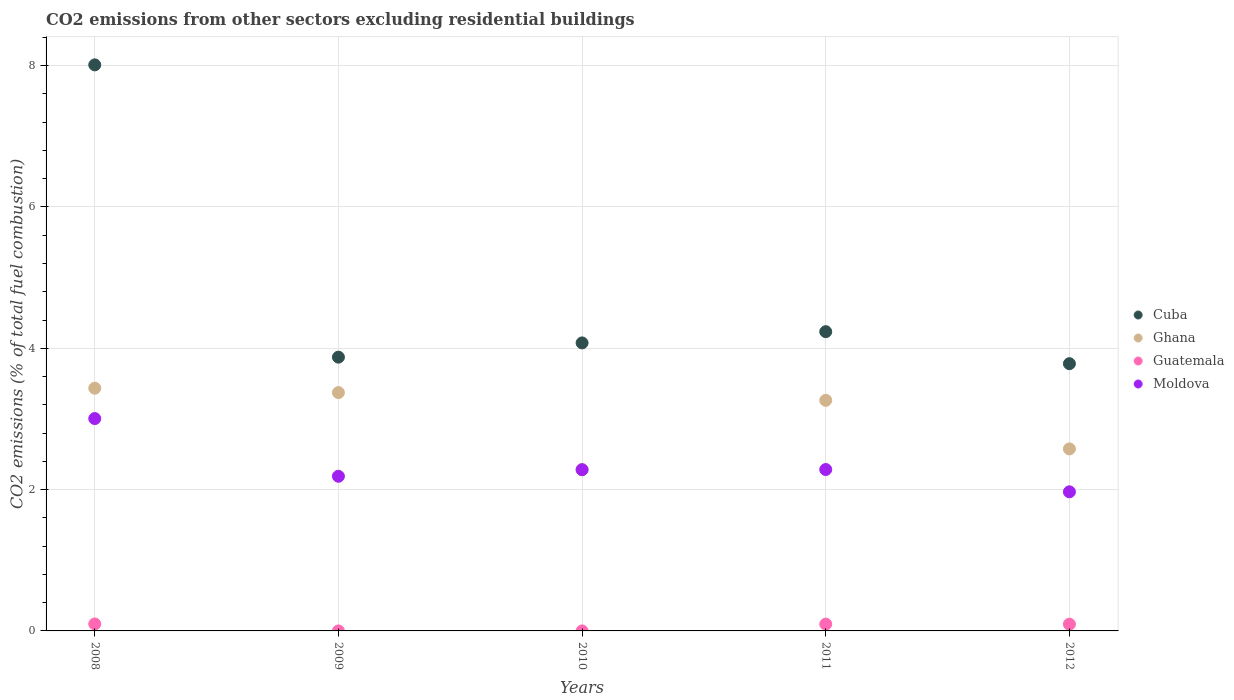How many different coloured dotlines are there?
Provide a succinct answer. 4. Is the number of dotlines equal to the number of legend labels?
Provide a short and direct response. Yes. What is the total CO2 emitted in Ghana in 2010?
Your answer should be compact. 2.28. Across all years, what is the maximum total CO2 emitted in Moldova?
Ensure brevity in your answer.  3.01. Across all years, what is the minimum total CO2 emitted in Ghana?
Ensure brevity in your answer.  2.28. What is the total total CO2 emitted in Cuba in the graph?
Make the answer very short. 23.98. What is the difference between the total CO2 emitted in Moldova in 2009 and that in 2010?
Your answer should be very brief. -0.09. What is the difference between the total CO2 emitted in Ghana in 2008 and the total CO2 emitted in Moldova in 2009?
Your response must be concise. 1.25. What is the average total CO2 emitted in Cuba per year?
Your response must be concise. 4.8. In the year 2012, what is the difference between the total CO2 emitted in Cuba and total CO2 emitted in Ghana?
Your answer should be compact. 1.21. What is the ratio of the total CO2 emitted in Moldova in 2009 to that in 2012?
Offer a very short reply. 1.11. Is the total CO2 emitted in Guatemala in 2008 less than that in 2011?
Keep it short and to the point. No. Is the difference between the total CO2 emitted in Cuba in 2009 and 2011 greater than the difference between the total CO2 emitted in Ghana in 2009 and 2011?
Give a very brief answer. No. What is the difference between the highest and the second highest total CO2 emitted in Ghana?
Offer a very short reply. 0.06. What is the difference between the highest and the lowest total CO2 emitted in Ghana?
Offer a very short reply. 1.15. Is it the case that in every year, the sum of the total CO2 emitted in Ghana and total CO2 emitted in Guatemala  is greater than the sum of total CO2 emitted in Moldova and total CO2 emitted in Cuba?
Provide a short and direct response. No. Does the total CO2 emitted in Moldova monotonically increase over the years?
Ensure brevity in your answer.  No. Is the total CO2 emitted in Ghana strictly less than the total CO2 emitted in Cuba over the years?
Offer a terse response. Yes. How many years are there in the graph?
Offer a terse response. 5. Are the values on the major ticks of Y-axis written in scientific E-notation?
Your answer should be very brief. No. Where does the legend appear in the graph?
Ensure brevity in your answer.  Center right. How are the legend labels stacked?
Keep it short and to the point. Vertical. What is the title of the graph?
Give a very brief answer. CO2 emissions from other sectors excluding residential buildings. What is the label or title of the Y-axis?
Provide a short and direct response. CO2 emissions (% of total fuel combustion). What is the CO2 emissions (% of total fuel combustion) in Cuba in 2008?
Make the answer very short. 8.01. What is the CO2 emissions (% of total fuel combustion) in Ghana in 2008?
Your answer should be very brief. 3.44. What is the CO2 emissions (% of total fuel combustion) of Guatemala in 2008?
Your response must be concise. 0.1. What is the CO2 emissions (% of total fuel combustion) of Moldova in 2008?
Ensure brevity in your answer.  3.01. What is the CO2 emissions (% of total fuel combustion) in Cuba in 2009?
Your answer should be very brief. 3.87. What is the CO2 emissions (% of total fuel combustion) of Ghana in 2009?
Make the answer very short. 3.37. What is the CO2 emissions (% of total fuel combustion) in Guatemala in 2009?
Ensure brevity in your answer.  7.793007529096171e-17. What is the CO2 emissions (% of total fuel combustion) of Moldova in 2009?
Ensure brevity in your answer.  2.19. What is the CO2 emissions (% of total fuel combustion) of Cuba in 2010?
Offer a terse response. 4.08. What is the CO2 emissions (% of total fuel combustion) in Ghana in 2010?
Your response must be concise. 2.28. What is the CO2 emissions (% of total fuel combustion) in Guatemala in 2010?
Your answer should be very brief. 1.6957218729001e-16. What is the CO2 emissions (% of total fuel combustion) in Moldova in 2010?
Offer a terse response. 2.28. What is the CO2 emissions (% of total fuel combustion) of Cuba in 2011?
Offer a terse response. 4.24. What is the CO2 emissions (% of total fuel combustion) of Ghana in 2011?
Your answer should be compact. 3.26. What is the CO2 emissions (% of total fuel combustion) in Guatemala in 2011?
Provide a succinct answer. 0.1. What is the CO2 emissions (% of total fuel combustion) in Moldova in 2011?
Make the answer very short. 2.28. What is the CO2 emissions (% of total fuel combustion) in Cuba in 2012?
Provide a succinct answer. 3.78. What is the CO2 emissions (% of total fuel combustion) of Ghana in 2012?
Your answer should be very brief. 2.58. What is the CO2 emissions (% of total fuel combustion) of Guatemala in 2012?
Keep it short and to the point. 0.1. What is the CO2 emissions (% of total fuel combustion) of Moldova in 2012?
Offer a terse response. 1.97. Across all years, what is the maximum CO2 emissions (% of total fuel combustion) of Cuba?
Your answer should be very brief. 8.01. Across all years, what is the maximum CO2 emissions (% of total fuel combustion) of Ghana?
Give a very brief answer. 3.44. Across all years, what is the maximum CO2 emissions (% of total fuel combustion) in Guatemala?
Keep it short and to the point. 0.1. Across all years, what is the maximum CO2 emissions (% of total fuel combustion) of Moldova?
Keep it short and to the point. 3.01. Across all years, what is the minimum CO2 emissions (% of total fuel combustion) in Cuba?
Offer a terse response. 3.78. Across all years, what is the minimum CO2 emissions (% of total fuel combustion) in Ghana?
Your answer should be compact. 2.28. Across all years, what is the minimum CO2 emissions (% of total fuel combustion) in Guatemala?
Provide a succinct answer. 7.793007529096171e-17. Across all years, what is the minimum CO2 emissions (% of total fuel combustion) of Moldova?
Your answer should be very brief. 1.97. What is the total CO2 emissions (% of total fuel combustion) in Cuba in the graph?
Offer a very short reply. 23.98. What is the total CO2 emissions (% of total fuel combustion) in Ghana in the graph?
Offer a very short reply. 14.93. What is the total CO2 emissions (% of total fuel combustion) in Guatemala in the graph?
Make the answer very short. 0.29. What is the total CO2 emissions (% of total fuel combustion) of Moldova in the graph?
Provide a succinct answer. 11.73. What is the difference between the CO2 emissions (% of total fuel combustion) in Cuba in 2008 and that in 2009?
Your answer should be compact. 4.14. What is the difference between the CO2 emissions (% of total fuel combustion) in Ghana in 2008 and that in 2009?
Provide a short and direct response. 0.06. What is the difference between the CO2 emissions (% of total fuel combustion) in Guatemala in 2008 and that in 2009?
Ensure brevity in your answer.  0.1. What is the difference between the CO2 emissions (% of total fuel combustion) in Moldova in 2008 and that in 2009?
Your response must be concise. 0.82. What is the difference between the CO2 emissions (% of total fuel combustion) of Cuba in 2008 and that in 2010?
Provide a short and direct response. 3.94. What is the difference between the CO2 emissions (% of total fuel combustion) of Ghana in 2008 and that in 2010?
Your answer should be very brief. 1.15. What is the difference between the CO2 emissions (% of total fuel combustion) in Guatemala in 2008 and that in 2010?
Offer a terse response. 0.1. What is the difference between the CO2 emissions (% of total fuel combustion) in Moldova in 2008 and that in 2010?
Your response must be concise. 0.72. What is the difference between the CO2 emissions (% of total fuel combustion) of Cuba in 2008 and that in 2011?
Offer a very short reply. 3.78. What is the difference between the CO2 emissions (% of total fuel combustion) in Ghana in 2008 and that in 2011?
Your answer should be compact. 0.17. What is the difference between the CO2 emissions (% of total fuel combustion) of Guatemala in 2008 and that in 2011?
Ensure brevity in your answer.  0. What is the difference between the CO2 emissions (% of total fuel combustion) in Moldova in 2008 and that in 2011?
Offer a terse response. 0.72. What is the difference between the CO2 emissions (% of total fuel combustion) in Cuba in 2008 and that in 2012?
Offer a very short reply. 4.23. What is the difference between the CO2 emissions (% of total fuel combustion) in Ghana in 2008 and that in 2012?
Provide a short and direct response. 0.86. What is the difference between the CO2 emissions (% of total fuel combustion) of Guatemala in 2008 and that in 2012?
Offer a terse response. 0. What is the difference between the CO2 emissions (% of total fuel combustion) of Cuba in 2009 and that in 2010?
Keep it short and to the point. -0.2. What is the difference between the CO2 emissions (% of total fuel combustion) in Ghana in 2009 and that in 2010?
Make the answer very short. 1.09. What is the difference between the CO2 emissions (% of total fuel combustion) of Moldova in 2009 and that in 2010?
Your response must be concise. -0.09. What is the difference between the CO2 emissions (% of total fuel combustion) of Cuba in 2009 and that in 2011?
Offer a terse response. -0.36. What is the difference between the CO2 emissions (% of total fuel combustion) in Ghana in 2009 and that in 2011?
Offer a very short reply. 0.11. What is the difference between the CO2 emissions (% of total fuel combustion) of Guatemala in 2009 and that in 2011?
Provide a succinct answer. -0.1. What is the difference between the CO2 emissions (% of total fuel combustion) of Moldova in 2009 and that in 2011?
Your answer should be very brief. -0.1. What is the difference between the CO2 emissions (% of total fuel combustion) in Cuba in 2009 and that in 2012?
Your answer should be compact. 0.09. What is the difference between the CO2 emissions (% of total fuel combustion) in Ghana in 2009 and that in 2012?
Ensure brevity in your answer.  0.8. What is the difference between the CO2 emissions (% of total fuel combustion) of Guatemala in 2009 and that in 2012?
Your response must be concise. -0.1. What is the difference between the CO2 emissions (% of total fuel combustion) in Moldova in 2009 and that in 2012?
Your response must be concise. 0.22. What is the difference between the CO2 emissions (% of total fuel combustion) in Cuba in 2010 and that in 2011?
Your response must be concise. -0.16. What is the difference between the CO2 emissions (% of total fuel combustion) in Ghana in 2010 and that in 2011?
Make the answer very short. -0.98. What is the difference between the CO2 emissions (% of total fuel combustion) in Guatemala in 2010 and that in 2011?
Keep it short and to the point. -0.1. What is the difference between the CO2 emissions (% of total fuel combustion) of Moldova in 2010 and that in 2011?
Your response must be concise. -0. What is the difference between the CO2 emissions (% of total fuel combustion) of Cuba in 2010 and that in 2012?
Provide a succinct answer. 0.29. What is the difference between the CO2 emissions (% of total fuel combustion) in Ghana in 2010 and that in 2012?
Keep it short and to the point. -0.29. What is the difference between the CO2 emissions (% of total fuel combustion) in Guatemala in 2010 and that in 2012?
Your response must be concise. -0.1. What is the difference between the CO2 emissions (% of total fuel combustion) in Moldova in 2010 and that in 2012?
Make the answer very short. 0.31. What is the difference between the CO2 emissions (% of total fuel combustion) in Cuba in 2011 and that in 2012?
Keep it short and to the point. 0.45. What is the difference between the CO2 emissions (% of total fuel combustion) in Ghana in 2011 and that in 2012?
Offer a very short reply. 0.69. What is the difference between the CO2 emissions (% of total fuel combustion) in Guatemala in 2011 and that in 2012?
Offer a very short reply. 0. What is the difference between the CO2 emissions (% of total fuel combustion) in Moldova in 2011 and that in 2012?
Your response must be concise. 0.32. What is the difference between the CO2 emissions (% of total fuel combustion) in Cuba in 2008 and the CO2 emissions (% of total fuel combustion) in Ghana in 2009?
Keep it short and to the point. 4.64. What is the difference between the CO2 emissions (% of total fuel combustion) of Cuba in 2008 and the CO2 emissions (% of total fuel combustion) of Guatemala in 2009?
Keep it short and to the point. 8.01. What is the difference between the CO2 emissions (% of total fuel combustion) in Cuba in 2008 and the CO2 emissions (% of total fuel combustion) in Moldova in 2009?
Your answer should be compact. 5.82. What is the difference between the CO2 emissions (% of total fuel combustion) in Ghana in 2008 and the CO2 emissions (% of total fuel combustion) in Guatemala in 2009?
Your response must be concise. 3.44. What is the difference between the CO2 emissions (% of total fuel combustion) in Ghana in 2008 and the CO2 emissions (% of total fuel combustion) in Moldova in 2009?
Keep it short and to the point. 1.25. What is the difference between the CO2 emissions (% of total fuel combustion) in Guatemala in 2008 and the CO2 emissions (% of total fuel combustion) in Moldova in 2009?
Offer a very short reply. -2.09. What is the difference between the CO2 emissions (% of total fuel combustion) of Cuba in 2008 and the CO2 emissions (% of total fuel combustion) of Ghana in 2010?
Your answer should be very brief. 5.73. What is the difference between the CO2 emissions (% of total fuel combustion) in Cuba in 2008 and the CO2 emissions (% of total fuel combustion) in Guatemala in 2010?
Provide a short and direct response. 8.01. What is the difference between the CO2 emissions (% of total fuel combustion) of Cuba in 2008 and the CO2 emissions (% of total fuel combustion) of Moldova in 2010?
Your response must be concise. 5.73. What is the difference between the CO2 emissions (% of total fuel combustion) of Ghana in 2008 and the CO2 emissions (% of total fuel combustion) of Guatemala in 2010?
Keep it short and to the point. 3.44. What is the difference between the CO2 emissions (% of total fuel combustion) of Ghana in 2008 and the CO2 emissions (% of total fuel combustion) of Moldova in 2010?
Your answer should be very brief. 1.15. What is the difference between the CO2 emissions (% of total fuel combustion) of Guatemala in 2008 and the CO2 emissions (% of total fuel combustion) of Moldova in 2010?
Your response must be concise. -2.18. What is the difference between the CO2 emissions (% of total fuel combustion) of Cuba in 2008 and the CO2 emissions (% of total fuel combustion) of Ghana in 2011?
Make the answer very short. 4.75. What is the difference between the CO2 emissions (% of total fuel combustion) in Cuba in 2008 and the CO2 emissions (% of total fuel combustion) in Guatemala in 2011?
Your response must be concise. 7.91. What is the difference between the CO2 emissions (% of total fuel combustion) in Cuba in 2008 and the CO2 emissions (% of total fuel combustion) in Moldova in 2011?
Offer a terse response. 5.73. What is the difference between the CO2 emissions (% of total fuel combustion) in Ghana in 2008 and the CO2 emissions (% of total fuel combustion) in Guatemala in 2011?
Keep it short and to the point. 3.34. What is the difference between the CO2 emissions (% of total fuel combustion) of Ghana in 2008 and the CO2 emissions (% of total fuel combustion) of Moldova in 2011?
Keep it short and to the point. 1.15. What is the difference between the CO2 emissions (% of total fuel combustion) of Guatemala in 2008 and the CO2 emissions (% of total fuel combustion) of Moldova in 2011?
Give a very brief answer. -2.19. What is the difference between the CO2 emissions (% of total fuel combustion) in Cuba in 2008 and the CO2 emissions (% of total fuel combustion) in Ghana in 2012?
Give a very brief answer. 5.43. What is the difference between the CO2 emissions (% of total fuel combustion) of Cuba in 2008 and the CO2 emissions (% of total fuel combustion) of Guatemala in 2012?
Make the answer very short. 7.92. What is the difference between the CO2 emissions (% of total fuel combustion) in Cuba in 2008 and the CO2 emissions (% of total fuel combustion) in Moldova in 2012?
Offer a terse response. 6.04. What is the difference between the CO2 emissions (% of total fuel combustion) in Ghana in 2008 and the CO2 emissions (% of total fuel combustion) in Guatemala in 2012?
Your answer should be compact. 3.34. What is the difference between the CO2 emissions (% of total fuel combustion) of Ghana in 2008 and the CO2 emissions (% of total fuel combustion) of Moldova in 2012?
Ensure brevity in your answer.  1.47. What is the difference between the CO2 emissions (% of total fuel combustion) of Guatemala in 2008 and the CO2 emissions (% of total fuel combustion) of Moldova in 2012?
Your answer should be compact. -1.87. What is the difference between the CO2 emissions (% of total fuel combustion) of Cuba in 2009 and the CO2 emissions (% of total fuel combustion) of Ghana in 2010?
Offer a very short reply. 1.59. What is the difference between the CO2 emissions (% of total fuel combustion) in Cuba in 2009 and the CO2 emissions (% of total fuel combustion) in Guatemala in 2010?
Provide a succinct answer. 3.87. What is the difference between the CO2 emissions (% of total fuel combustion) of Cuba in 2009 and the CO2 emissions (% of total fuel combustion) of Moldova in 2010?
Ensure brevity in your answer.  1.59. What is the difference between the CO2 emissions (% of total fuel combustion) of Ghana in 2009 and the CO2 emissions (% of total fuel combustion) of Guatemala in 2010?
Provide a succinct answer. 3.37. What is the difference between the CO2 emissions (% of total fuel combustion) in Ghana in 2009 and the CO2 emissions (% of total fuel combustion) in Moldova in 2010?
Provide a succinct answer. 1.09. What is the difference between the CO2 emissions (% of total fuel combustion) of Guatemala in 2009 and the CO2 emissions (% of total fuel combustion) of Moldova in 2010?
Your response must be concise. -2.28. What is the difference between the CO2 emissions (% of total fuel combustion) in Cuba in 2009 and the CO2 emissions (% of total fuel combustion) in Ghana in 2011?
Make the answer very short. 0.61. What is the difference between the CO2 emissions (% of total fuel combustion) in Cuba in 2009 and the CO2 emissions (% of total fuel combustion) in Guatemala in 2011?
Offer a very short reply. 3.78. What is the difference between the CO2 emissions (% of total fuel combustion) of Cuba in 2009 and the CO2 emissions (% of total fuel combustion) of Moldova in 2011?
Your answer should be very brief. 1.59. What is the difference between the CO2 emissions (% of total fuel combustion) of Ghana in 2009 and the CO2 emissions (% of total fuel combustion) of Guatemala in 2011?
Your answer should be very brief. 3.28. What is the difference between the CO2 emissions (% of total fuel combustion) of Ghana in 2009 and the CO2 emissions (% of total fuel combustion) of Moldova in 2011?
Provide a short and direct response. 1.09. What is the difference between the CO2 emissions (% of total fuel combustion) in Guatemala in 2009 and the CO2 emissions (% of total fuel combustion) in Moldova in 2011?
Offer a terse response. -2.28. What is the difference between the CO2 emissions (% of total fuel combustion) in Cuba in 2009 and the CO2 emissions (% of total fuel combustion) in Ghana in 2012?
Provide a short and direct response. 1.3. What is the difference between the CO2 emissions (% of total fuel combustion) of Cuba in 2009 and the CO2 emissions (% of total fuel combustion) of Guatemala in 2012?
Ensure brevity in your answer.  3.78. What is the difference between the CO2 emissions (% of total fuel combustion) of Cuba in 2009 and the CO2 emissions (% of total fuel combustion) of Moldova in 2012?
Offer a terse response. 1.91. What is the difference between the CO2 emissions (% of total fuel combustion) in Ghana in 2009 and the CO2 emissions (% of total fuel combustion) in Guatemala in 2012?
Give a very brief answer. 3.28. What is the difference between the CO2 emissions (% of total fuel combustion) of Ghana in 2009 and the CO2 emissions (% of total fuel combustion) of Moldova in 2012?
Your answer should be compact. 1.4. What is the difference between the CO2 emissions (% of total fuel combustion) in Guatemala in 2009 and the CO2 emissions (% of total fuel combustion) in Moldova in 2012?
Offer a very short reply. -1.97. What is the difference between the CO2 emissions (% of total fuel combustion) of Cuba in 2010 and the CO2 emissions (% of total fuel combustion) of Ghana in 2011?
Your response must be concise. 0.81. What is the difference between the CO2 emissions (% of total fuel combustion) in Cuba in 2010 and the CO2 emissions (% of total fuel combustion) in Guatemala in 2011?
Your answer should be very brief. 3.98. What is the difference between the CO2 emissions (% of total fuel combustion) in Cuba in 2010 and the CO2 emissions (% of total fuel combustion) in Moldova in 2011?
Ensure brevity in your answer.  1.79. What is the difference between the CO2 emissions (% of total fuel combustion) of Ghana in 2010 and the CO2 emissions (% of total fuel combustion) of Guatemala in 2011?
Make the answer very short. 2.19. What is the difference between the CO2 emissions (% of total fuel combustion) in Ghana in 2010 and the CO2 emissions (% of total fuel combustion) in Moldova in 2011?
Offer a very short reply. -0. What is the difference between the CO2 emissions (% of total fuel combustion) in Guatemala in 2010 and the CO2 emissions (% of total fuel combustion) in Moldova in 2011?
Keep it short and to the point. -2.28. What is the difference between the CO2 emissions (% of total fuel combustion) of Cuba in 2010 and the CO2 emissions (% of total fuel combustion) of Ghana in 2012?
Give a very brief answer. 1.5. What is the difference between the CO2 emissions (% of total fuel combustion) of Cuba in 2010 and the CO2 emissions (% of total fuel combustion) of Guatemala in 2012?
Your response must be concise. 3.98. What is the difference between the CO2 emissions (% of total fuel combustion) of Cuba in 2010 and the CO2 emissions (% of total fuel combustion) of Moldova in 2012?
Keep it short and to the point. 2.11. What is the difference between the CO2 emissions (% of total fuel combustion) of Ghana in 2010 and the CO2 emissions (% of total fuel combustion) of Guatemala in 2012?
Give a very brief answer. 2.19. What is the difference between the CO2 emissions (% of total fuel combustion) of Ghana in 2010 and the CO2 emissions (% of total fuel combustion) of Moldova in 2012?
Your response must be concise. 0.32. What is the difference between the CO2 emissions (% of total fuel combustion) in Guatemala in 2010 and the CO2 emissions (% of total fuel combustion) in Moldova in 2012?
Your response must be concise. -1.97. What is the difference between the CO2 emissions (% of total fuel combustion) of Cuba in 2011 and the CO2 emissions (% of total fuel combustion) of Ghana in 2012?
Your response must be concise. 1.66. What is the difference between the CO2 emissions (% of total fuel combustion) of Cuba in 2011 and the CO2 emissions (% of total fuel combustion) of Guatemala in 2012?
Provide a succinct answer. 4.14. What is the difference between the CO2 emissions (% of total fuel combustion) of Cuba in 2011 and the CO2 emissions (% of total fuel combustion) of Moldova in 2012?
Your answer should be very brief. 2.27. What is the difference between the CO2 emissions (% of total fuel combustion) of Ghana in 2011 and the CO2 emissions (% of total fuel combustion) of Guatemala in 2012?
Your response must be concise. 3.17. What is the difference between the CO2 emissions (% of total fuel combustion) of Ghana in 2011 and the CO2 emissions (% of total fuel combustion) of Moldova in 2012?
Provide a succinct answer. 1.3. What is the difference between the CO2 emissions (% of total fuel combustion) in Guatemala in 2011 and the CO2 emissions (% of total fuel combustion) in Moldova in 2012?
Provide a succinct answer. -1.87. What is the average CO2 emissions (% of total fuel combustion) in Cuba per year?
Make the answer very short. 4.8. What is the average CO2 emissions (% of total fuel combustion) of Ghana per year?
Provide a succinct answer. 2.99. What is the average CO2 emissions (% of total fuel combustion) in Guatemala per year?
Give a very brief answer. 0.06. What is the average CO2 emissions (% of total fuel combustion) of Moldova per year?
Give a very brief answer. 2.35. In the year 2008, what is the difference between the CO2 emissions (% of total fuel combustion) of Cuba and CO2 emissions (% of total fuel combustion) of Ghana?
Keep it short and to the point. 4.58. In the year 2008, what is the difference between the CO2 emissions (% of total fuel combustion) of Cuba and CO2 emissions (% of total fuel combustion) of Guatemala?
Ensure brevity in your answer.  7.91. In the year 2008, what is the difference between the CO2 emissions (% of total fuel combustion) of Cuba and CO2 emissions (% of total fuel combustion) of Moldova?
Your answer should be compact. 5.01. In the year 2008, what is the difference between the CO2 emissions (% of total fuel combustion) of Ghana and CO2 emissions (% of total fuel combustion) of Guatemala?
Keep it short and to the point. 3.34. In the year 2008, what is the difference between the CO2 emissions (% of total fuel combustion) of Ghana and CO2 emissions (% of total fuel combustion) of Moldova?
Your answer should be very brief. 0.43. In the year 2008, what is the difference between the CO2 emissions (% of total fuel combustion) in Guatemala and CO2 emissions (% of total fuel combustion) in Moldova?
Offer a terse response. -2.91. In the year 2009, what is the difference between the CO2 emissions (% of total fuel combustion) in Cuba and CO2 emissions (% of total fuel combustion) in Ghana?
Make the answer very short. 0.5. In the year 2009, what is the difference between the CO2 emissions (% of total fuel combustion) of Cuba and CO2 emissions (% of total fuel combustion) of Guatemala?
Provide a short and direct response. 3.87. In the year 2009, what is the difference between the CO2 emissions (% of total fuel combustion) in Cuba and CO2 emissions (% of total fuel combustion) in Moldova?
Your answer should be compact. 1.69. In the year 2009, what is the difference between the CO2 emissions (% of total fuel combustion) in Ghana and CO2 emissions (% of total fuel combustion) in Guatemala?
Provide a short and direct response. 3.37. In the year 2009, what is the difference between the CO2 emissions (% of total fuel combustion) of Ghana and CO2 emissions (% of total fuel combustion) of Moldova?
Make the answer very short. 1.18. In the year 2009, what is the difference between the CO2 emissions (% of total fuel combustion) of Guatemala and CO2 emissions (% of total fuel combustion) of Moldova?
Your answer should be very brief. -2.19. In the year 2010, what is the difference between the CO2 emissions (% of total fuel combustion) in Cuba and CO2 emissions (% of total fuel combustion) in Ghana?
Make the answer very short. 1.79. In the year 2010, what is the difference between the CO2 emissions (% of total fuel combustion) of Cuba and CO2 emissions (% of total fuel combustion) of Guatemala?
Provide a succinct answer. 4.08. In the year 2010, what is the difference between the CO2 emissions (% of total fuel combustion) in Cuba and CO2 emissions (% of total fuel combustion) in Moldova?
Provide a short and direct response. 1.79. In the year 2010, what is the difference between the CO2 emissions (% of total fuel combustion) of Ghana and CO2 emissions (% of total fuel combustion) of Guatemala?
Offer a terse response. 2.28. In the year 2010, what is the difference between the CO2 emissions (% of total fuel combustion) in Ghana and CO2 emissions (% of total fuel combustion) in Moldova?
Ensure brevity in your answer.  0. In the year 2010, what is the difference between the CO2 emissions (% of total fuel combustion) in Guatemala and CO2 emissions (% of total fuel combustion) in Moldova?
Offer a terse response. -2.28. In the year 2011, what is the difference between the CO2 emissions (% of total fuel combustion) in Cuba and CO2 emissions (% of total fuel combustion) in Ghana?
Your answer should be very brief. 0.97. In the year 2011, what is the difference between the CO2 emissions (% of total fuel combustion) of Cuba and CO2 emissions (% of total fuel combustion) of Guatemala?
Make the answer very short. 4.14. In the year 2011, what is the difference between the CO2 emissions (% of total fuel combustion) of Cuba and CO2 emissions (% of total fuel combustion) of Moldova?
Provide a succinct answer. 1.95. In the year 2011, what is the difference between the CO2 emissions (% of total fuel combustion) of Ghana and CO2 emissions (% of total fuel combustion) of Guatemala?
Offer a very short reply. 3.17. In the year 2011, what is the difference between the CO2 emissions (% of total fuel combustion) of Ghana and CO2 emissions (% of total fuel combustion) of Moldova?
Ensure brevity in your answer.  0.98. In the year 2011, what is the difference between the CO2 emissions (% of total fuel combustion) in Guatemala and CO2 emissions (% of total fuel combustion) in Moldova?
Keep it short and to the point. -2.19. In the year 2012, what is the difference between the CO2 emissions (% of total fuel combustion) of Cuba and CO2 emissions (% of total fuel combustion) of Ghana?
Provide a succinct answer. 1.21. In the year 2012, what is the difference between the CO2 emissions (% of total fuel combustion) in Cuba and CO2 emissions (% of total fuel combustion) in Guatemala?
Provide a short and direct response. 3.69. In the year 2012, what is the difference between the CO2 emissions (% of total fuel combustion) of Cuba and CO2 emissions (% of total fuel combustion) of Moldova?
Offer a terse response. 1.81. In the year 2012, what is the difference between the CO2 emissions (% of total fuel combustion) in Ghana and CO2 emissions (% of total fuel combustion) in Guatemala?
Ensure brevity in your answer.  2.48. In the year 2012, what is the difference between the CO2 emissions (% of total fuel combustion) of Ghana and CO2 emissions (% of total fuel combustion) of Moldova?
Offer a very short reply. 0.61. In the year 2012, what is the difference between the CO2 emissions (% of total fuel combustion) in Guatemala and CO2 emissions (% of total fuel combustion) in Moldova?
Keep it short and to the point. -1.87. What is the ratio of the CO2 emissions (% of total fuel combustion) in Cuba in 2008 to that in 2009?
Make the answer very short. 2.07. What is the ratio of the CO2 emissions (% of total fuel combustion) in Ghana in 2008 to that in 2009?
Provide a short and direct response. 1.02. What is the ratio of the CO2 emissions (% of total fuel combustion) of Guatemala in 2008 to that in 2009?
Your answer should be very brief. 1.26e+15. What is the ratio of the CO2 emissions (% of total fuel combustion) of Moldova in 2008 to that in 2009?
Keep it short and to the point. 1.37. What is the ratio of the CO2 emissions (% of total fuel combustion) of Cuba in 2008 to that in 2010?
Make the answer very short. 1.97. What is the ratio of the CO2 emissions (% of total fuel combustion) of Ghana in 2008 to that in 2010?
Your response must be concise. 1.5. What is the ratio of the CO2 emissions (% of total fuel combustion) in Guatemala in 2008 to that in 2010?
Provide a succinct answer. 5.81e+14. What is the ratio of the CO2 emissions (% of total fuel combustion) in Moldova in 2008 to that in 2010?
Give a very brief answer. 1.32. What is the ratio of the CO2 emissions (% of total fuel combustion) in Cuba in 2008 to that in 2011?
Provide a short and direct response. 1.89. What is the ratio of the CO2 emissions (% of total fuel combustion) of Ghana in 2008 to that in 2011?
Offer a very short reply. 1.05. What is the ratio of the CO2 emissions (% of total fuel combustion) of Guatemala in 2008 to that in 2011?
Your answer should be very brief. 1.02. What is the ratio of the CO2 emissions (% of total fuel combustion) in Moldova in 2008 to that in 2011?
Your answer should be compact. 1.32. What is the ratio of the CO2 emissions (% of total fuel combustion) of Cuba in 2008 to that in 2012?
Provide a succinct answer. 2.12. What is the ratio of the CO2 emissions (% of total fuel combustion) in Ghana in 2008 to that in 2012?
Offer a very short reply. 1.33. What is the ratio of the CO2 emissions (% of total fuel combustion) in Guatemala in 2008 to that in 2012?
Offer a terse response. 1.03. What is the ratio of the CO2 emissions (% of total fuel combustion) of Moldova in 2008 to that in 2012?
Offer a very short reply. 1.53. What is the ratio of the CO2 emissions (% of total fuel combustion) of Cuba in 2009 to that in 2010?
Keep it short and to the point. 0.95. What is the ratio of the CO2 emissions (% of total fuel combustion) in Ghana in 2009 to that in 2010?
Offer a terse response. 1.48. What is the ratio of the CO2 emissions (% of total fuel combustion) of Guatemala in 2009 to that in 2010?
Your response must be concise. 0.46. What is the ratio of the CO2 emissions (% of total fuel combustion) of Moldova in 2009 to that in 2010?
Ensure brevity in your answer.  0.96. What is the ratio of the CO2 emissions (% of total fuel combustion) of Cuba in 2009 to that in 2011?
Offer a terse response. 0.91. What is the ratio of the CO2 emissions (% of total fuel combustion) of Ghana in 2009 to that in 2011?
Offer a terse response. 1.03. What is the ratio of the CO2 emissions (% of total fuel combustion) of Guatemala in 2009 to that in 2011?
Provide a short and direct response. 0. What is the ratio of the CO2 emissions (% of total fuel combustion) of Moldova in 2009 to that in 2011?
Provide a short and direct response. 0.96. What is the ratio of the CO2 emissions (% of total fuel combustion) of Cuba in 2009 to that in 2012?
Your answer should be compact. 1.02. What is the ratio of the CO2 emissions (% of total fuel combustion) in Ghana in 2009 to that in 2012?
Give a very brief answer. 1.31. What is the ratio of the CO2 emissions (% of total fuel combustion) in Guatemala in 2009 to that in 2012?
Provide a succinct answer. 0. What is the ratio of the CO2 emissions (% of total fuel combustion) of Moldova in 2009 to that in 2012?
Your response must be concise. 1.11. What is the ratio of the CO2 emissions (% of total fuel combustion) in Cuba in 2010 to that in 2011?
Keep it short and to the point. 0.96. What is the ratio of the CO2 emissions (% of total fuel combustion) of Ghana in 2010 to that in 2011?
Offer a very short reply. 0.7. What is the ratio of the CO2 emissions (% of total fuel combustion) in Moldova in 2010 to that in 2011?
Make the answer very short. 1. What is the ratio of the CO2 emissions (% of total fuel combustion) of Cuba in 2010 to that in 2012?
Your response must be concise. 1.08. What is the ratio of the CO2 emissions (% of total fuel combustion) in Ghana in 2010 to that in 2012?
Your response must be concise. 0.89. What is the ratio of the CO2 emissions (% of total fuel combustion) in Guatemala in 2010 to that in 2012?
Your answer should be very brief. 0. What is the ratio of the CO2 emissions (% of total fuel combustion) of Moldova in 2010 to that in 2012?
Provide a short and direct response. 1.16. What is the ratio of the CO2 emissions (% of total fuel combustion) of Cuba in 2011 to that in 2012?
Make the answer very short. 1.12. What is the ratio of the CO2 emissions (% of total fuel combustion) of Ghana in 2011 to that in 2012?
Ensure brevity in your answer.  1.27. What is the ratio of the CO2 emissions (% of total fuel combustion) of Guatemala in 2011 to that in 2012?
Offer a very short reply. 1.01. What is the ratio of the CO2 emissions (% of total fuel combustion) in Moldova in 2011 to that in 2012?
Keep it short and to the point. 1.16. What is the difference between the highest and the second highest CO2 emissions (% of total fuel combustion) of Cuba?
Your response must be concise. 3.78. What is the difference between the highest and the second highest CO2 emissions (% of total fuel combustion) of Ghana?
Your answer should be compact. 0.06. What is the difference between the highest and the second highest CO2 emissions (% of total fuel combustion) of Guatemala?
Make the answer very short. 0. What is the difference between the highest and the second highest CO2 emissions (% of total fuel combustion) in Moldova?
Keep it short and to the point. 0.72. What is the difference between the highest and the lowest CO2 emissions (% of total fuel combustion) of Cuba?
Your answer should be compact. 4.23. What is the difference between the highest and the lowest CO2 emissions (% of total fuel combustion) of Ghana?
Provide a succinct answer. 1.15. What is the difference between the highest and the lowest CO2 emissions (% of total fuel combustion) in Guatemala?
Your response must be concise. 0.1. What is the difference between the highest and the lowest CO2 emissions (% of total fuel combustion) in Moldova?
Your answer should be very brief. 1.04. 